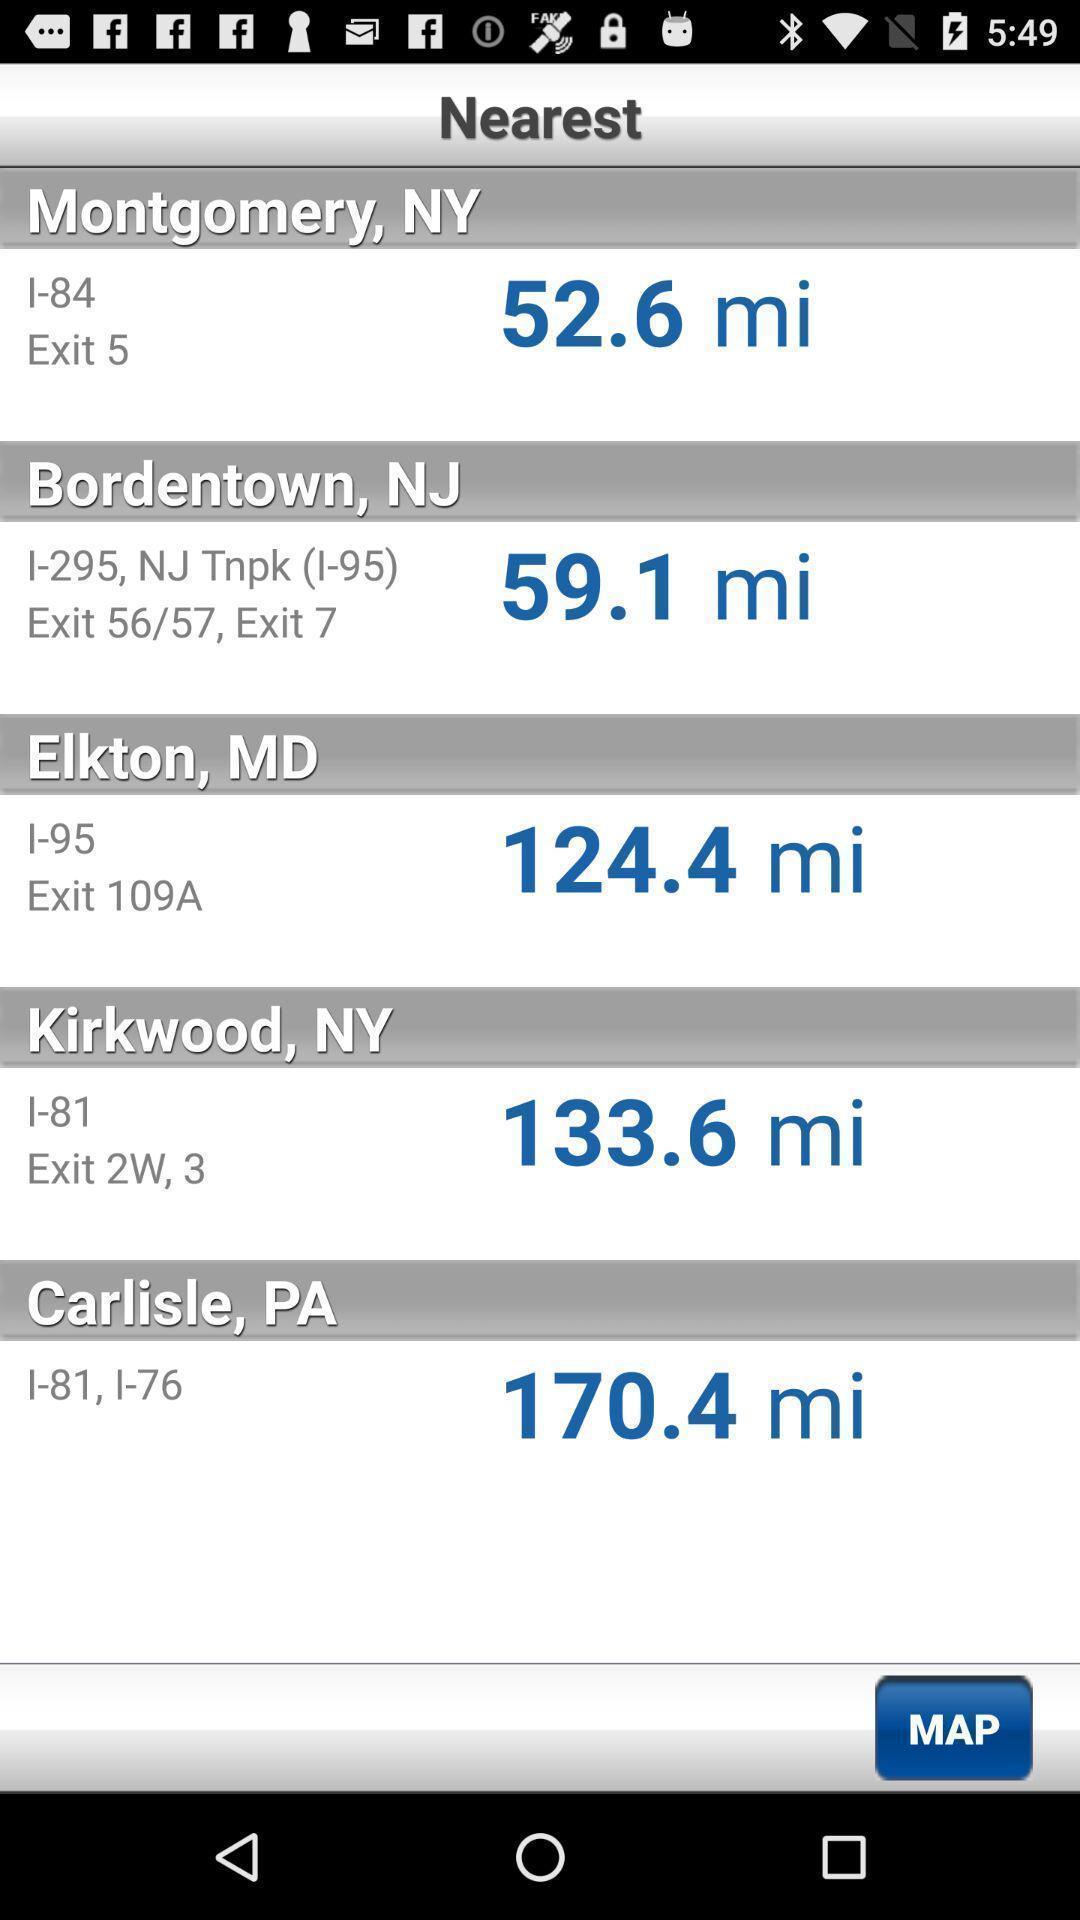Tell me about the visual elements in this screen capture. Page showing nearest destinations in a truck washing app. 